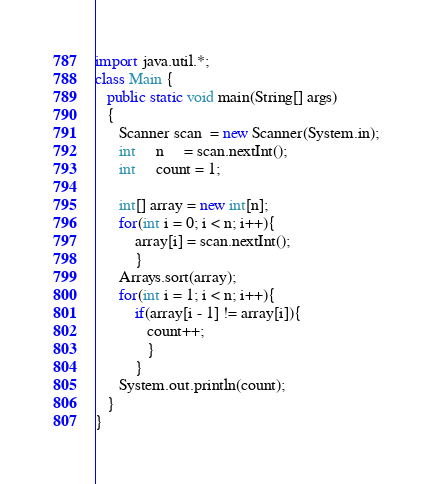<code> <loc_0><loc_0><loc_500><loc_500><_Java_>import java.util.*;
class Main {
   public static void main(String[] args)
   {
      Scanner scan  = new Scanner(System.in);
      int     n     = scan.nextInt();
      int     count = 1;

      int[] array = new int[n];
      for(int i = 0; i < n; i++){
          array[i] = scan.nextInt();
          }
      Arrays.sort(array);
      for(int i = 1; i < n; i++){
          if(array[i - 1] != array[i]){
             count++;
             }
          }
      System.out.println(count);
   }
}
</code> 